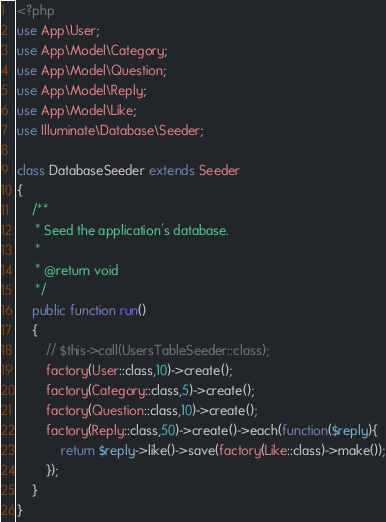Convert code to text. <code><loc_0><loc_0><loc_500><loc_500><_PHP_><?php
use App\User;
use App\Model\Category;
use App\Model\Question;
use App\Model\Reply;
use App\Model\Like;
use Illuminate\Database\Seeder;

class DatabaseSeeder extends Seeder
{
    /**
     * Seed the application's database.
     *
     * @return void
     */
    public function run()
    {
        // $this->call(UsersTableSeeder::class);
        factory(User::class,10)->create();
        factory(Category::class,5)->create();
        factory(Question::class,10)->create();
        factory(Reply::class,50)->create()->each(function($reply){
        	return $reply->like()->save(factory(Like::class)->make());
        });
    }
}
</code> 